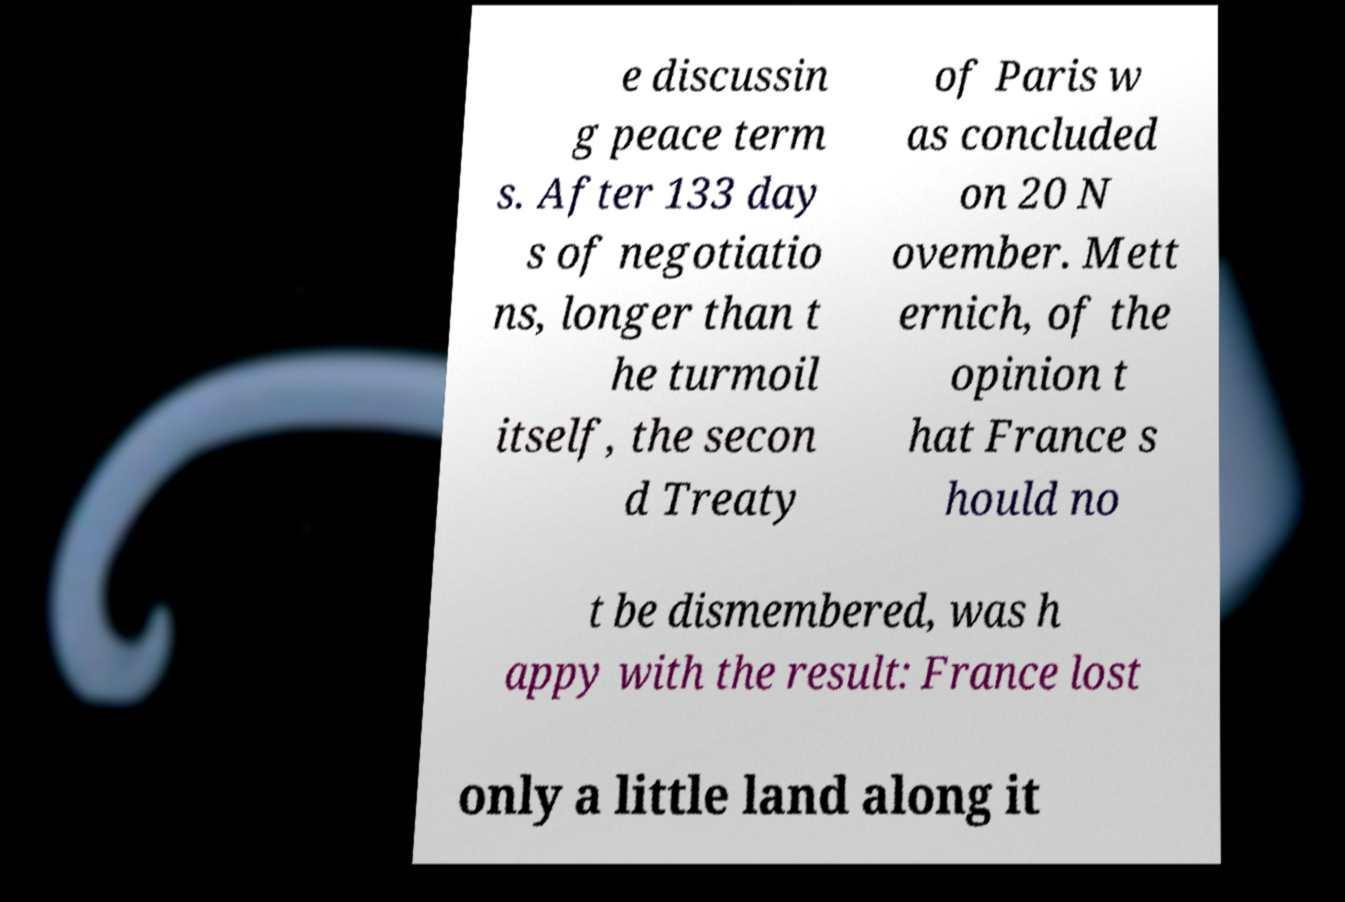Could you assist in decoding the text presented in this image and type it out clearly? e discussin g peace term s. After 133 day s of negotiatio ns, longer than t he turmoil itself, the secon d Treaty of Paris w as concluded on 20 N ovember. Mett ernich, of the opinion t hat France s hould no t be dismembered, was h appy with the result: France lost only a little land along it 